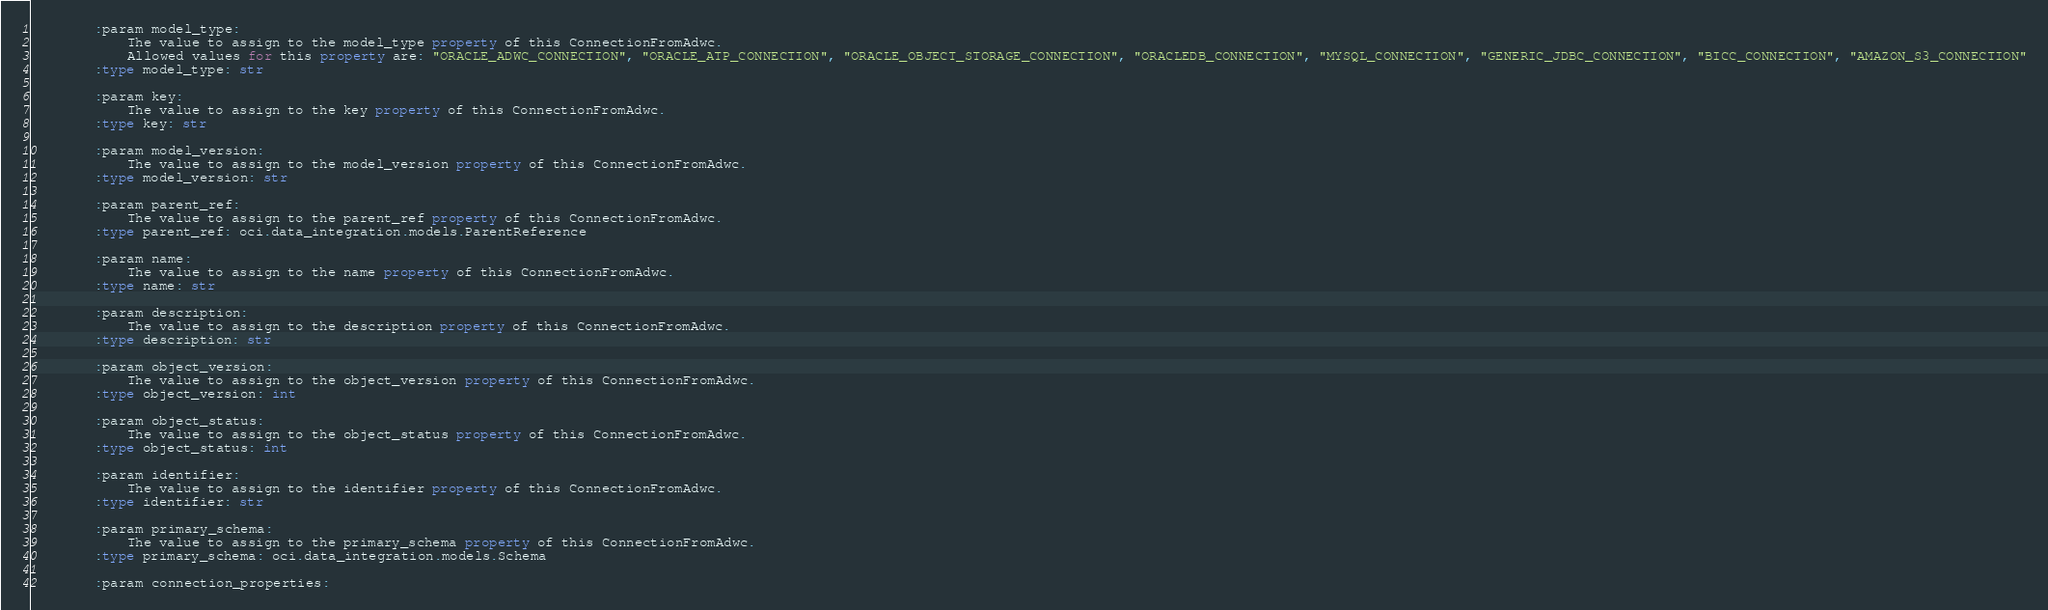<code> <loc_0><loc_0><loc_500><loc_500><_Python_>        :param model_type:
            The value to assign to the model_type property of this ConnectionFromAdwc.
            Allowed values for this property are: "ORACLE_ADWC_CONNECTION", "ORACLE_ATP_CONNECTION", "ORACLE_OBJECT_STORAGE_CONNECTION", "ORACLEDB_CONNECTION", "MYSQL_CONNECTION", "GENERIC_JDBC_CONNECTION", "BICC_CONNECTION", "AMAZON_S3_CONNECTION"
        :type model_type: str

        :param key:
            The value to assign to the key property of this ConnectionFromAdwc.
        :type key: str

        :param model_version:
            The value to assign to the model_version property of this ConnectionFromAdwc.
        :type model_version: str

        :param parent_ref:
            The value to assign to the parent_ref property of this ConnectionFromAdwc.
        :type parent_ref: oci.data_integration.models.ParentReference

        :param name:
            The value to assign to the name property of this ConnectionFromAdwc.
        :type name: str

        :param description:
            The value to assign to the description property of this ConnectionFromAdwc.
        :type description: str

        :param object_version:
            The value to assign to the object_version property of this ConnectionFromAdwc.
        :type object_version: int

        :param object_status:
            The value to assign to the object_status property of this ConnectionFromAdwc.
        :type object_status: int

        :param identifier:
            The value to assign to the identifier property of this ConnectionFromAdwc.
        :type identifier: str

        :param primary_schema:
            The value to assign to the primary_schema property of this ConnectionFromAdwc.
        :type primary_schema: oci.data_integration.models.Schema

        :param connection_properties:</code> 